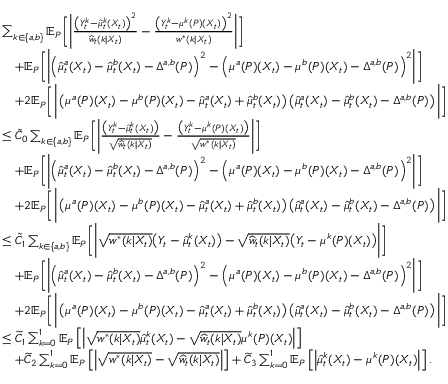<formula> <loc_0><loc_0><loc_500><loc_500>\begin{array} { r l } & { \sum _ { k \in \{ a , b \} } \mathbb { E } _ { P } \left [ \left | \frac { \left ( Y _ { t } ^ { k } - \widehat { \mu } _ { t } ^ { k } ( X _ { t } ) \right ) ^ { 2 } } { \widehat { w } _ { t } ( k | X _ { t } ) } - \frac { \left ( Y _ { t } ^ { k } - \mu ^ { k } ( P ) ( X _ { t } ) \right ) ^ { 2 } } { w ^ { * } ( k | X _ { t } ) } \right | \right ] } \\ & { \quad + \mathbb { E } _ { P } \left [ \left | \left ( \widehat { \mu } _ { t } ^ { a } ( X _ { t } ) - \widehat { \mu } _ { t } ^ { b } ( X _ { t } ) - \Delta ^ { a , b } ( P ) \right ) ^ { 2 } - \left ( \mu ^ { a } ( P ) ( X _ { t } ) - \mu ^ { b } ( P ) ( X _ { t } ) - \Delta ^ { a , b } ( P ) \right ) ^ { 2 } \right | \right ] } \\ & { \quad + 2 \mathbb { E } _ { P } \left [ \left | \left ( \mu ^ { a } ( P ) ( X _ { t } ) - \mu ^ { b } ( P ) ( X _ { t } ) - \widehat { \mu } _ { t } ^ { a } ( X _ { t } ) + \widehat { \mu } _ { t } ^ { b } ( X _ { t } ) \right ) \left ( \widehat { \mu } _ { t } ^ { a } ( X _ { t } ) - \widehat { \mu } _ { t } ^ { b } ( X _ { t } ) - \Delta ^ { a , b } ( P ) \right ) \right | \right ] } \\ & { \leq \tilde { C } _ { 0 } \sum _ { k \in \{ a , b \} } \mathbb { E } _ { P } \left [ \left | \frac { \left ( Y _ { t } ^ { k } - \widehat { \mu } _ { t } ^ { k } ( X _ { t } ) \right ) } { \sqrt { \widehat { w } _ { t } ( k | X _ { t } ) } } - \frac { \left ( Y _ { t } ^ { k } - \mu ^ { k } ( P ) ( X _ { t } ) \right ) } { \sqrt { w ^ { * } ( k | X _ { t } ) } } \right | \right ] } \\ & { \quad + \mathbb { E } _ { P } \left [ \left | \left ( \widehat { \mu } _ { t } ^ { a } ( X _ { t } ) - \widehat { \mu } _ { t } ^ { b } ( X _ { t } ) - \Delta ^ { a , b } ( P ) \right ) ^ { 2 } - \left ( \mu ^ { a } ( P ) ( X _ { t } ) - \mu ^ { b } ( P ) ( X _ { t } ) - \Delta ^ { a , b } ( P ) \right ) ^ { 2 } \right | \right ] } \\ & { \quad + 2 \mathbb { E } _ { P } \left [ \left | \left ( \mu ^ { a } ( P ) ( X _ { t } ) - \mu ^ { b } ( P ) ( X _ { t } ) - \widehat { \mu } _ { t } ^ { a } ( X _ { t } ) + \widehat { \mu } _ { t } ^ { b } ( X _ { t } ) \right ) \left ( \widehat { \mu } _ { t } ^ { a } ( X _ { t } ) - \widehat { \mu } _ { t } ^ { b } ( X _ { t } ) - \Delta ^ { a , b } ( P ) \right ) \right | \right ] } \\ & { \leq \tilde { C } _ { 1 } \sum _ { k \in \{ a , b \} } \mathbb { E } _ { P } \left [ \left | \sqrt { w ^ { * } ( k | X _ { t } ) } \left ( Y _ { t } - \widehat { \mu } _ { t } ^ { k } ( X _ { t } ) \right ) - \sqrt { \widehat { w } _ { t } ( k | X _ { t } ) } \left ( Y _ { t } - \mu ^ { k } ( P ) ( X _ { t } ) \right ) \right | \right ] } \\ & { \quad + \mathbb { E } _ { P } \left [ \left | \left ( \widehat { \mu } _ { t } ^ { a } ( X _ { t } ) - \widehat { \mu } _ { t } ^ { b } ( X _ { t } ) - \Delta ^ { a , b } ( P ) \right ) ^ { 2 } - \left ( \mu ^ { a } ( P ) ( X _ { t } ) - \mu ^ { b } ( P ) ( X _ { t } ) - \Delta ^ { a , b } ( P ) \right ) ^ { 2 } \right | \right ] } \\ & { \quad + 2 \mathbb { E } _ { P } \left [ \left | \left ( \mu ^ { a } ( P ) ( X _ { t } ) - \mu ^ { b } ( P ) ( X _ { t } ) - \widehat { \mu } _ { t } ^ { a } ( X _ { t } ) + \widehat { \mu } _ { t } ^ { b } ( X _ { t } ) \right ) \left ( \widehat { \mu } _ { t } ^ { a } ( X _ { t } ) - \widehat { \mu } _ { t } ^ { b } ( X _ { t } ) - \Delta ^ { a , b } ( P ) \right ) \right | \right ] } \\ & { \leq \widetilde { C } _ { 1 } \sum _ { k = 0 } ^ { 1 } \mathbb { E } _ { P } \left [ \left | \sqrt { w ^ { * } ( k | X _ { t } ) } \widehat { \mu } _ { t } ^ { k } ( X _ { t } ) - \sqrt { \widehat { w } _ { t } ( k | X _ { t } ) } \mu ^ { k } ( P ) ( X _ { t } ) \right | \right ] } \\ & { \quad + \widetilde { C } _ { 2 } \sum _ { k = 0 } ^ { 1 } \mathbb { E } _ { P } \left [ \left | \sqrt { w ^ { * } ( k | X _ { t } ) } - \sqrt { \widehat { w } _ { t } ( k | X _ { t } ) } \right | \right ] + \widetilde { C } _ { 3 } \sum _ { k = 0 } ^ { 1 } \mathbb { E } _ { P } \left [ \left | \widehat { \mu } _ { t } ^ { k } ( X _ { t } ) - \mu ^ { k } ( P ) ( X _ { t } ) \right | \right ] . } \end{array}</formula> 